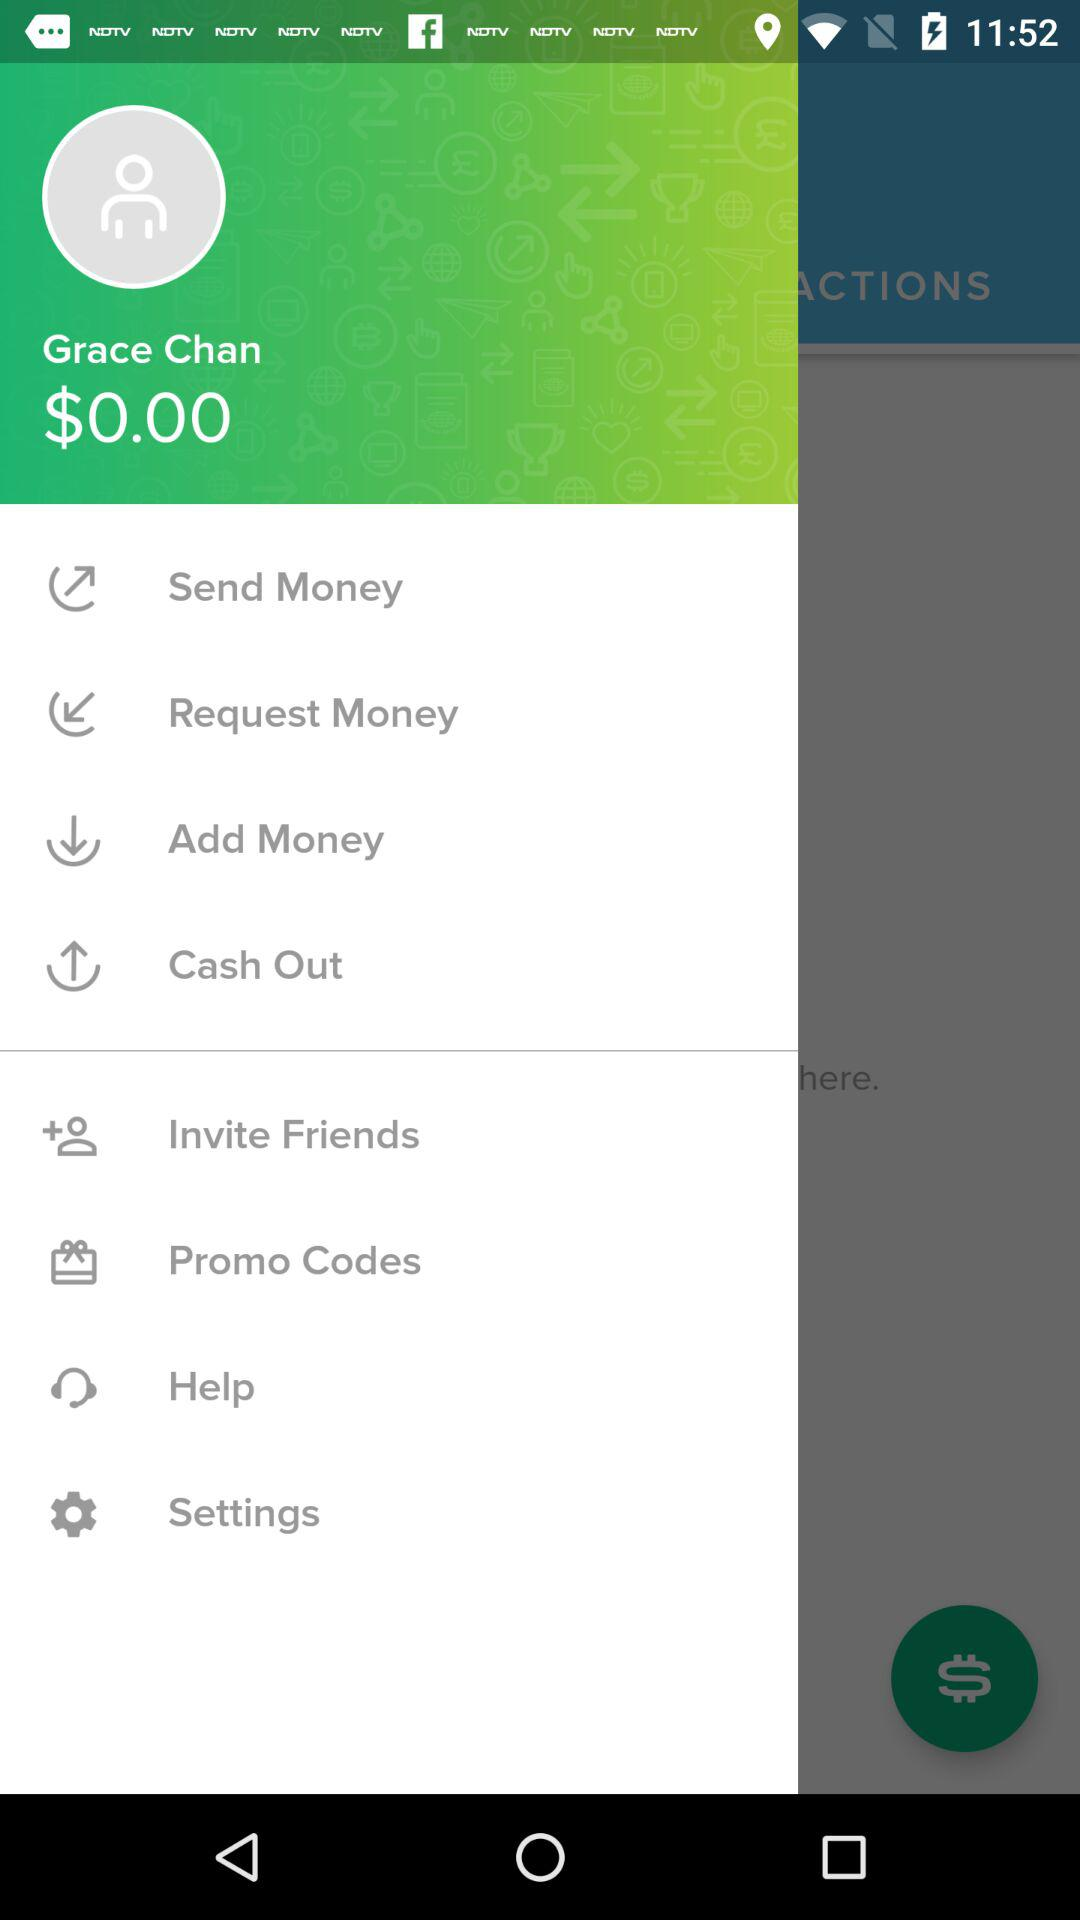How much cash is shown? $0.00 is shown on the screenshot. 